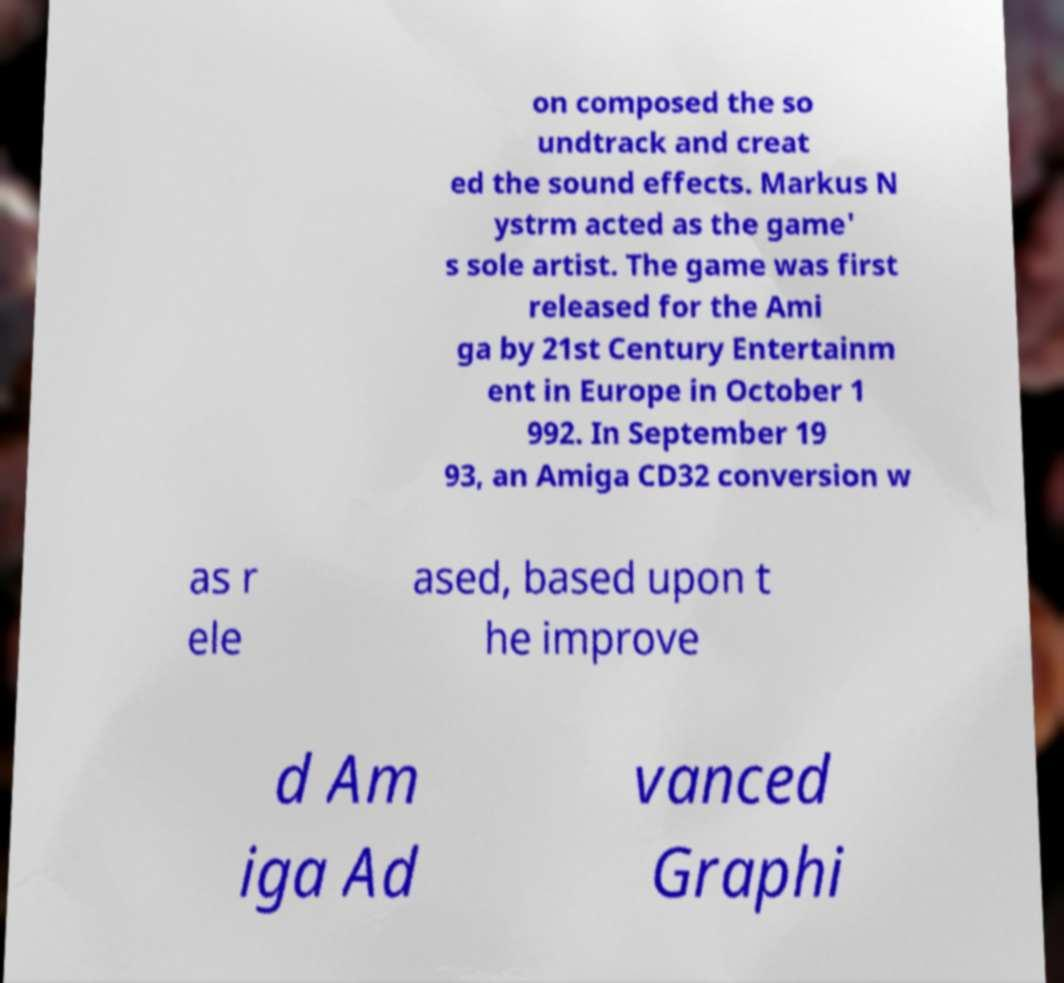Could you extract and type out the text from this image? on composed the so undtrack and creat ed the sound effects. Markus N ystrm acted as the game' s sole artist. The game was first released for the Ami ga by 21st Century Entertainm ent in Europe in October 1 992. In September 19 93, an Amiga CD32 conversion w as r ele ased, based upon t he improve d Am iga Ad vanced Graphi 